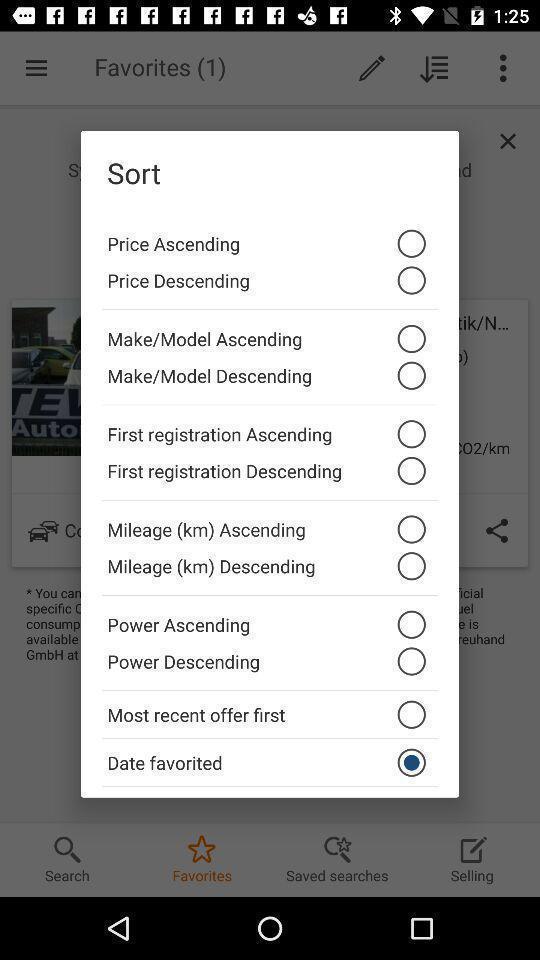Summarize the information in this screenshot. Pop-up showing different options like date favorited to select. 